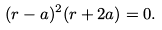<formula> <loc_0><loc_0><loc_500><loc_500>( r - a ) ^ { 2 } ( r + 2 a ) = 0 .</formula> 